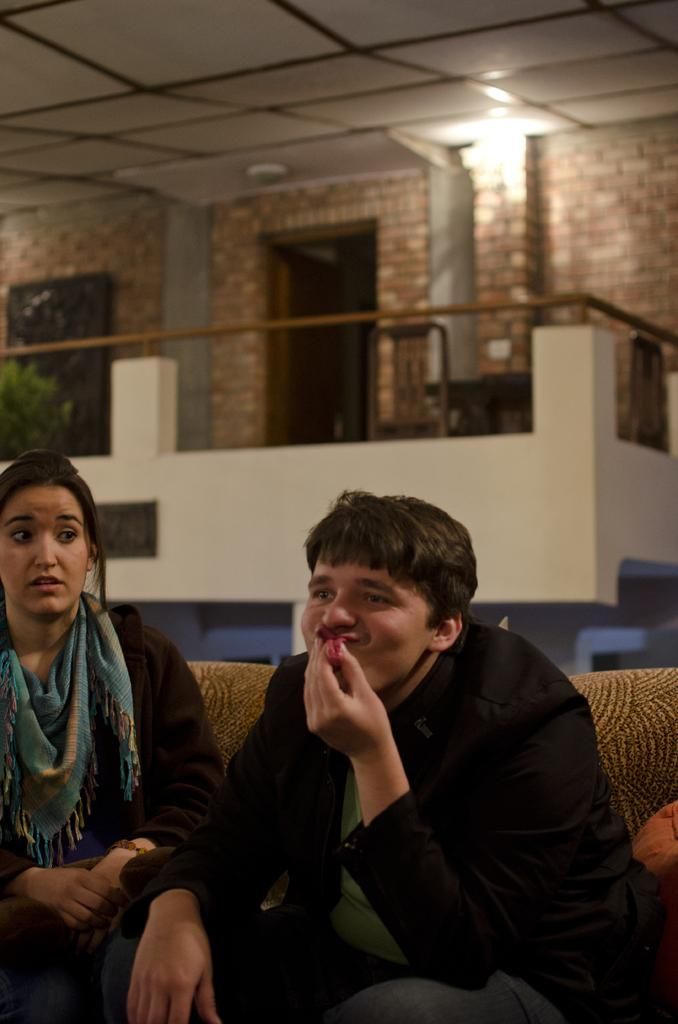How many people are sitting on the sofa in the image? There are two people sitting on the sofa in the image. What is visible on one of the people in the image? There is a scarf visible in the image. What is located behind the people on the sofa? There is a plant at the back of the people. What type of furniture is present in the image besides the sofa? There is a table and chairs in the image. What can be seen providing illumination in the image? There is a light in the image. What type of structure is visible in the background of the image? There is a wall in the image. What other objects can be seen in the image? There are some objects in the image. Can you tell me how many volleyballs are on the table in the image? There are no volleyballs present in the image. What type of payment is being made by the people sitting on the sofa in the image? There is no payment being made in the image; it only shows two people sitting on a sofa. 